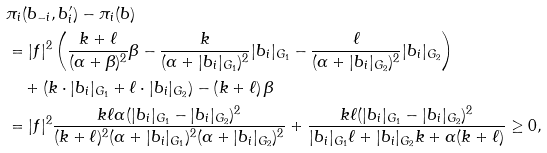<formula> <loc_0><loc_0><loc_500><loc_500>& \pi _ { i } ( b _ { - i } , b _ { i } ^ { \prime } ) - \pi _ { i } ( b ) \\ & = | f | ^ { 2 } \left ( \frac { k + \ell } { ( \alpha + \beta ) ^ { 2 } } \beta - \frac { k } { ( \alpha + | b _ { i } | _ { G _ { 1 } } ) ^ { 2 } } | b _ { i } | _ { G _ { 1 } } - \frac { \ell } { ( \alpha + | b _ { i } | _ { G _ { 2 } } ) ^ { 2 } } | b _ { i } | _ { G _ { 2 } } \right ) \\ & \quad + \left ( k \cdot | b _ { i } | _ { G _ { 1 } } + \ell \cdot | b _ { i } | _ { G _ { 2 } } \right ) - \left ( k + \ell \right ) \beta \\ & = | f | ^ { 2 } \frac { k \ell \alpha ( | b _ { i } | _ { G _ { 1 } } - | b _ { i } | _ { G _ { 2 } } ) ^ { 2 } } { ( k + \ell ) ^ { 2 } ( \alpha + | b _ { i } | _ { G _ { 1 } } ) ^ { 2 } ( \alpha + | b _ { i } | _ { G _ { 2 } } ) ^ { 2 } } + \frac { k \ell ( | b _ { i } | _ { G _ { 1 } } - | b _ { i } | _ { G _ { 2 } } ) ^ { 2 } } { | b _ { i } | _ { G _ { 1 } } \ell + | b _ { i } | _ { G _ { 2 } } k + \alpha ( k + \ell ) } \geq 0 ,</formula> 